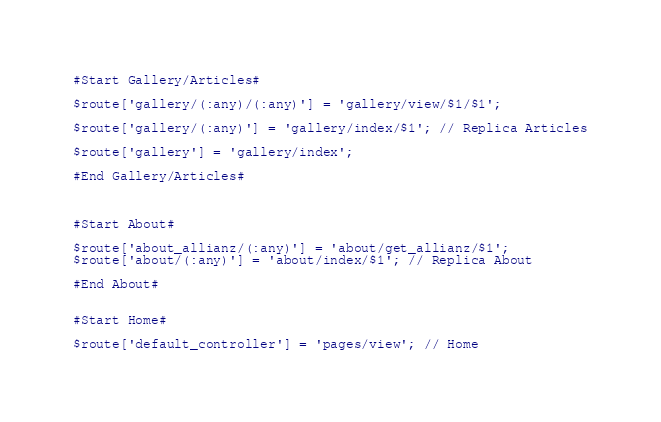<code> <loc_0><loc_0><loc_500><loc_500><_PHP_>

#Start Gallery/Articles#

$route['gallery/(:any)/(:any)'] = 'gallery/view/$1/$1';

$route['gallery/(:any)'] = 'gallery/index/$1'; // Replica Articles

$route['gallery'] = 'gallery/index';

#End Gallery/Articles#



#Start About#

$route['about_allianz/(:any)'] = 'about/get_allianz/$1'; 
$route['about/(:any)'] = 'about/index/$1'; // Replica About

#End About#


#Start Home#

$route['default_controller'] = 'pages/view'; // Home
</code> 